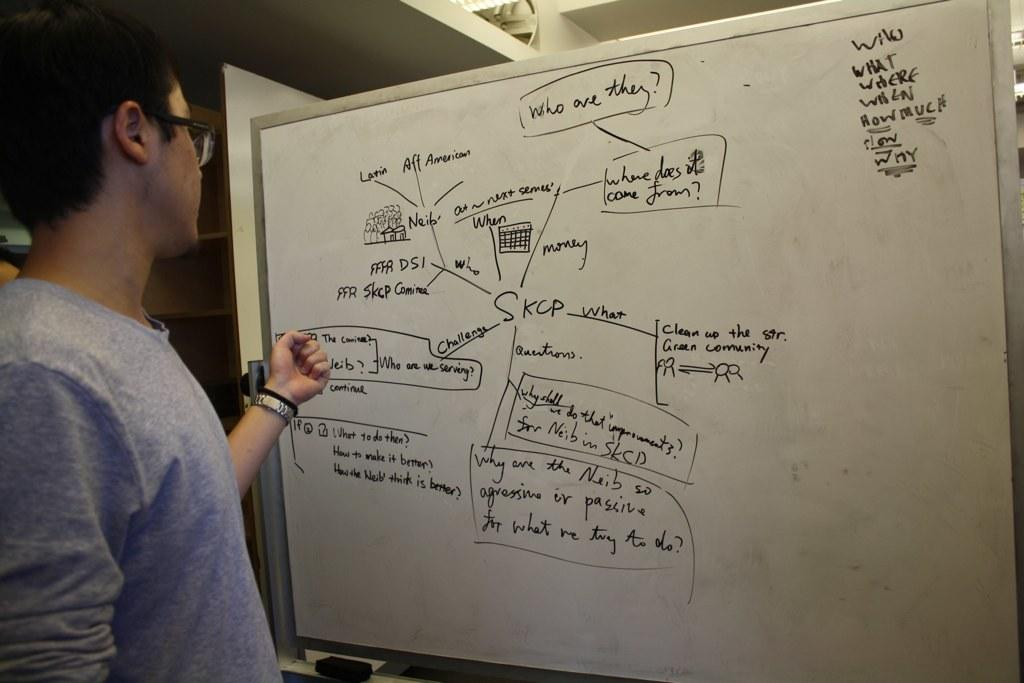<image>
Write a terse but informative summary of the picture. A man standing in front of a handwritten diagram that reads Who are they?. 